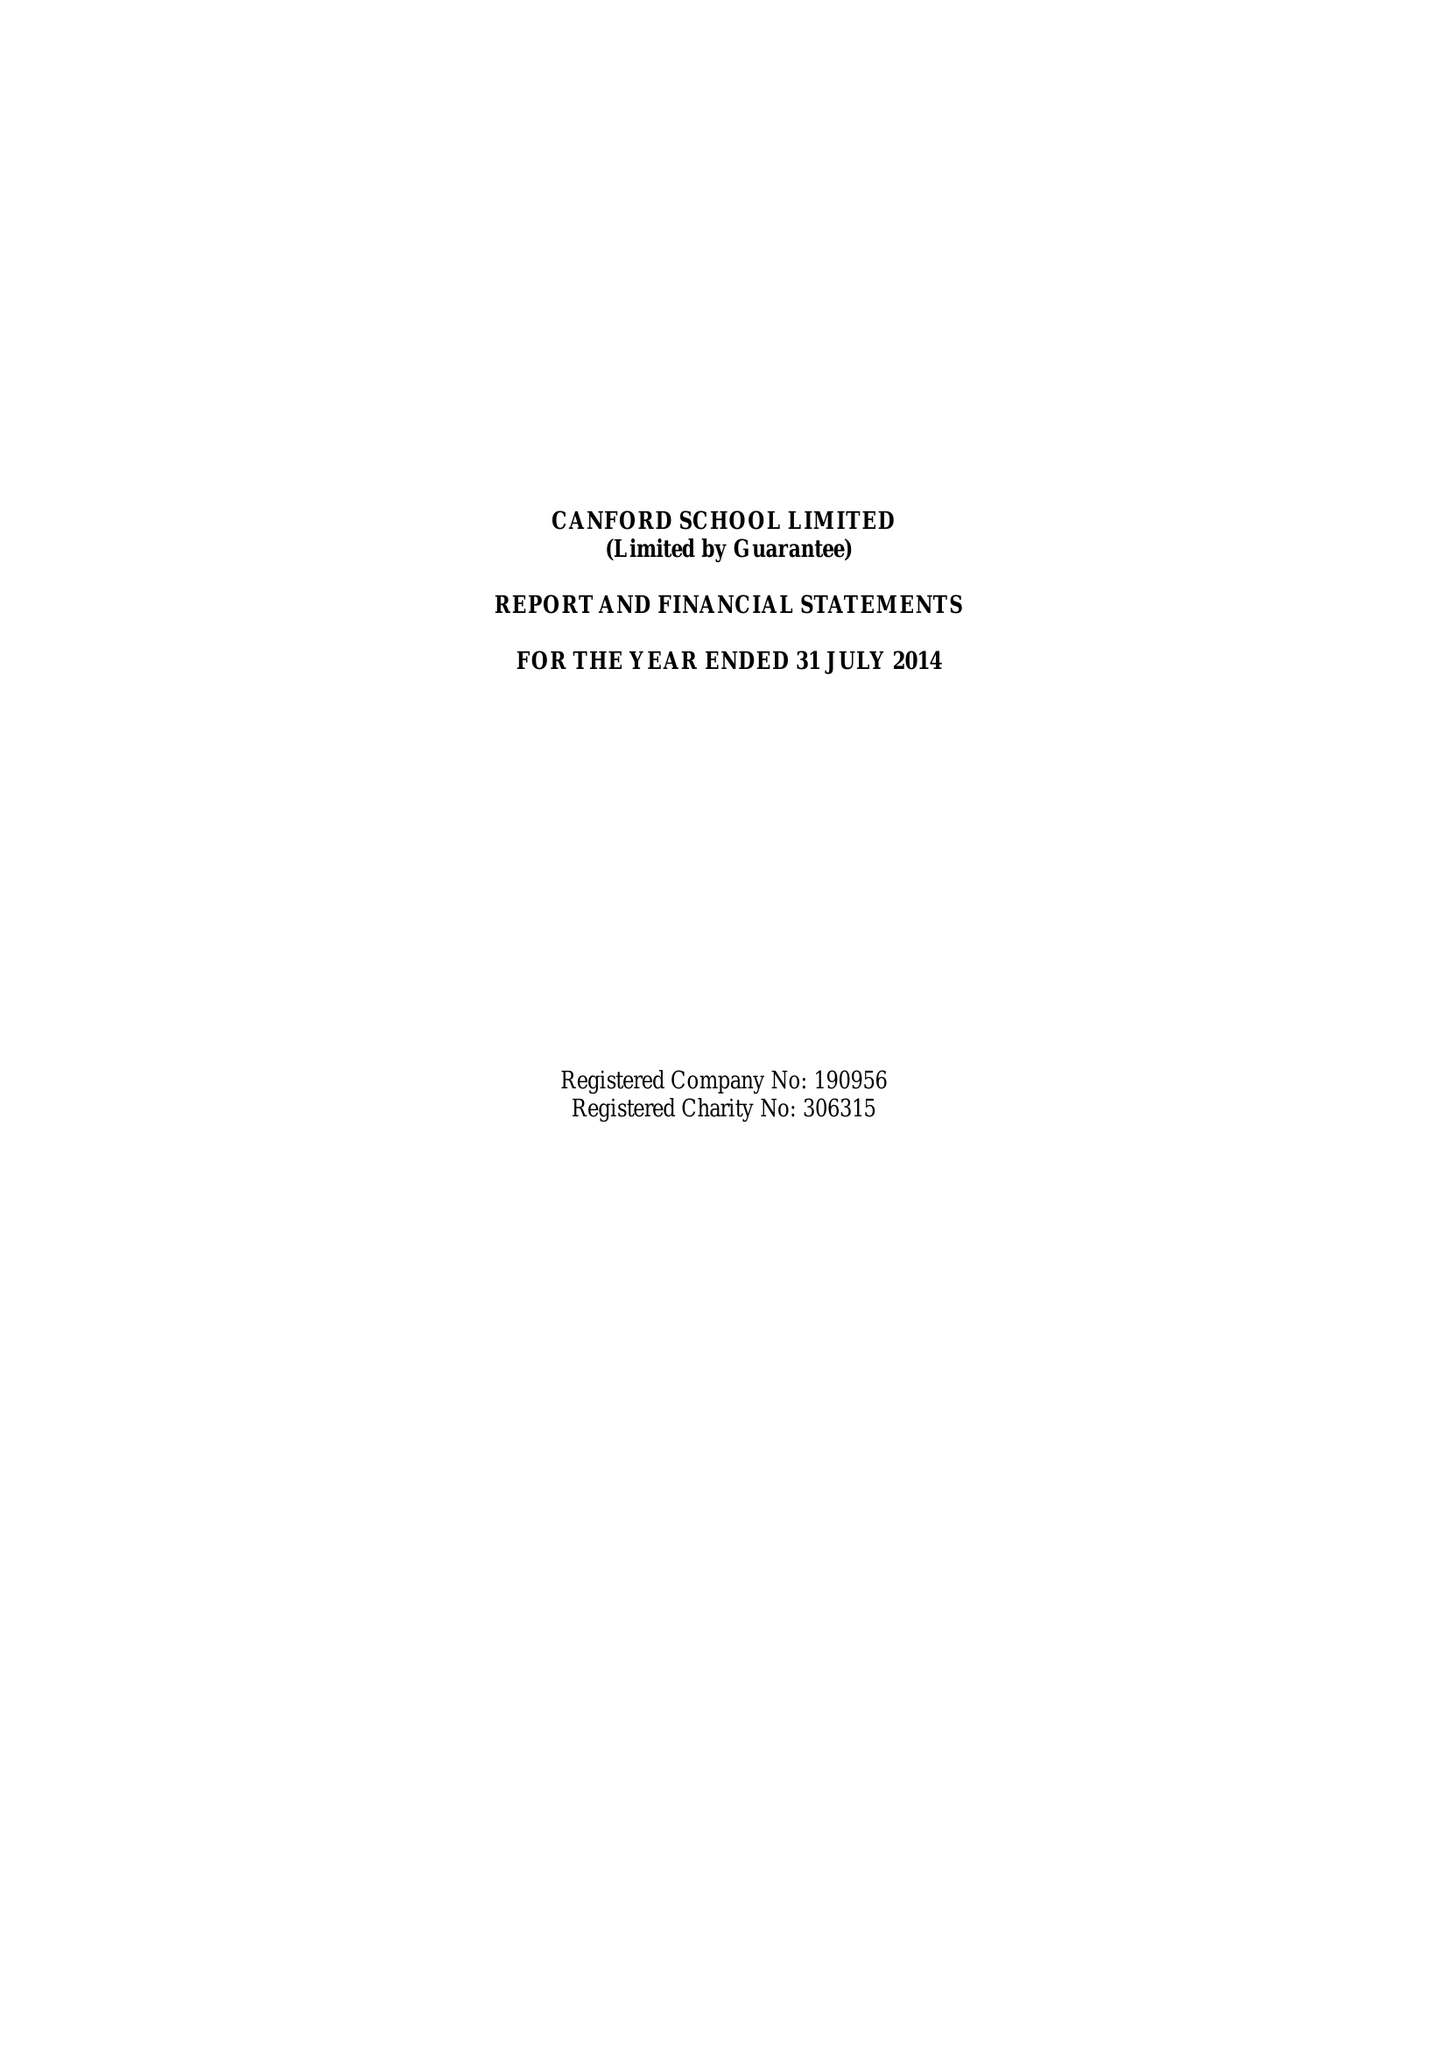What is the value for the address__postcode?
Answer the question using a single word or phrase. BH21 3AD 